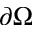<formula> <loc_0><loc_0><loc_500><loc_500>\partial \Omega</formula> 